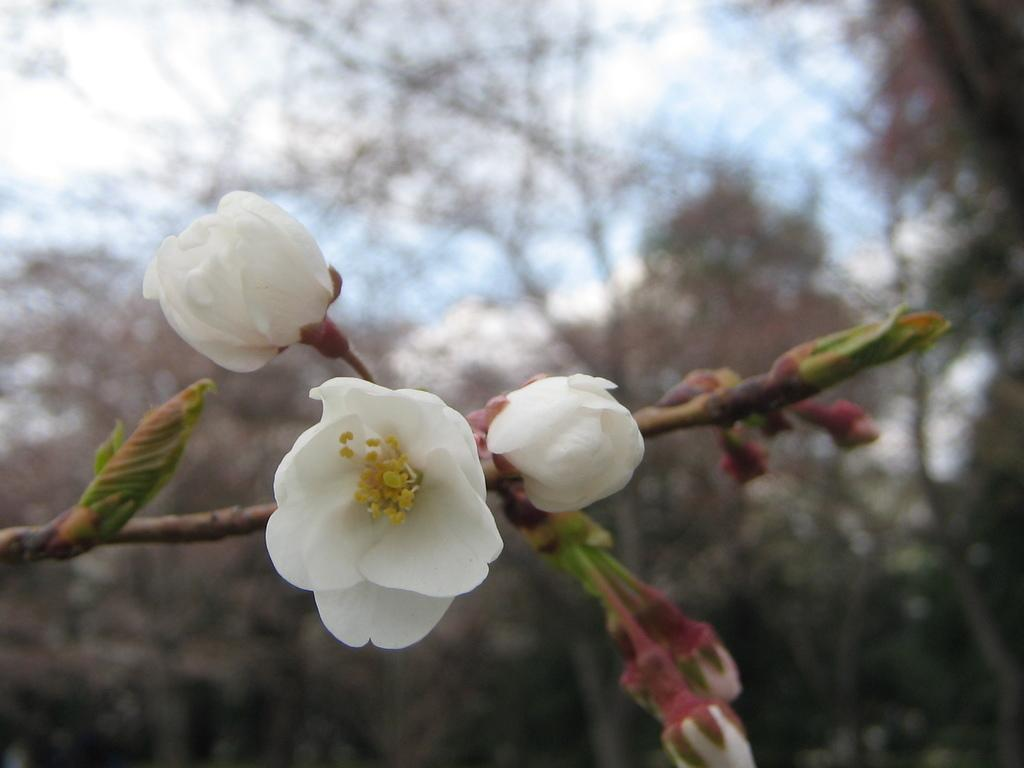What color are the flowers on the plant in the image? The flowers on the plant are white. What stage of growth are some of the flowers in? There are buds on the plant, indicating that some flowers are not yet fully bloomed. What can be seen in the background of the image? Trees are visible at the back, and the sky is visible at the top of the image. What is the condition of the sky in the image? The sky has clouds in it. What type of riddle is written on the leaf in the image? There is no leaf or riddle present in the image. What is the cause of death for the flowers in the image? There is no indication of death for the flowers in the image; they are still blooming and growing. 